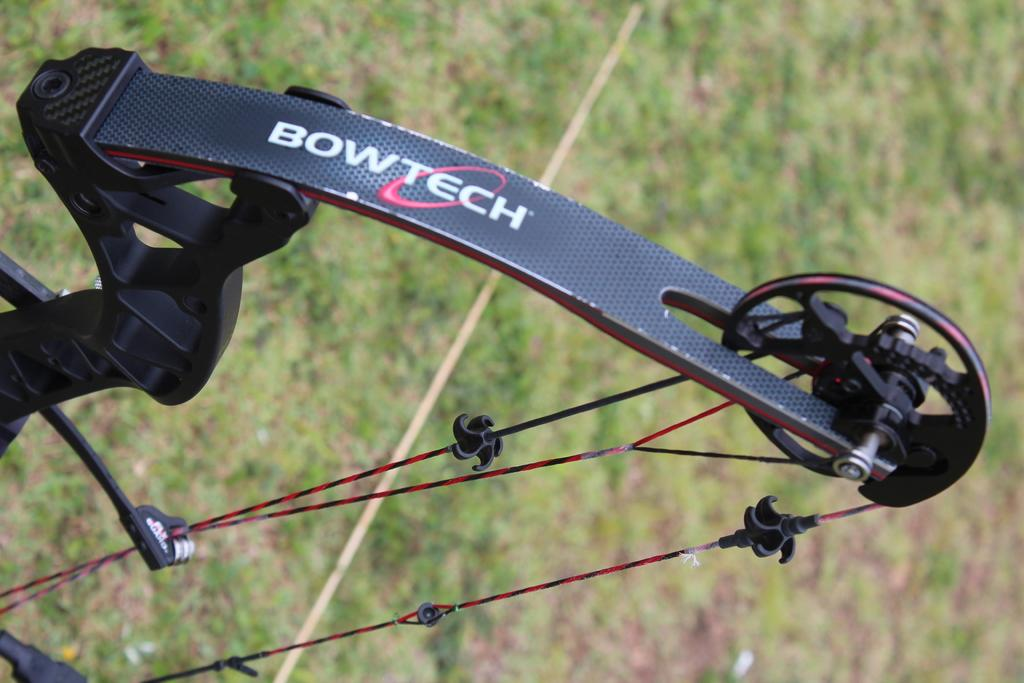What object is the main focus of the image? There is a bow in the image. Can you describe the background of the image? The background of the bow is blurred. What type of relation does the bow have with the tub in the image? There is no tub present in the image, so the bow does not have any relation with a tub. 